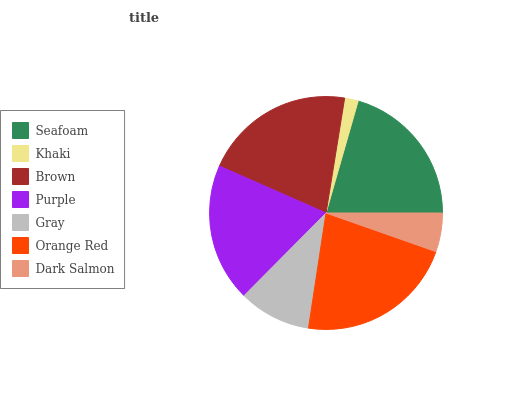Is Khaki the minimum?
Answer yes or no. Yes. Is Orange Red the maximum?
Answer yes or no. Yes. Is Brown the minimum?
Answer yes or no. No. Is Brown the maximum?
Answer yes or no. No. Is Brown greater than Khaki?
Answer yes or no. Yes. Is Khaki less than Brown?
Answer yes or no. Yes. Is Khaki greater than Brown?
Answer yes or no. No. Is Brown less than Khaki?
Answer yes or no. No. Is Purple the high median?
Answer yes or no. Yes. Is Purple the low median?
Answer yes or no. Yes. Is Khaki the high median?
Answer yes or no. No. Is Gray the low median?
Answer yes or no. No. 